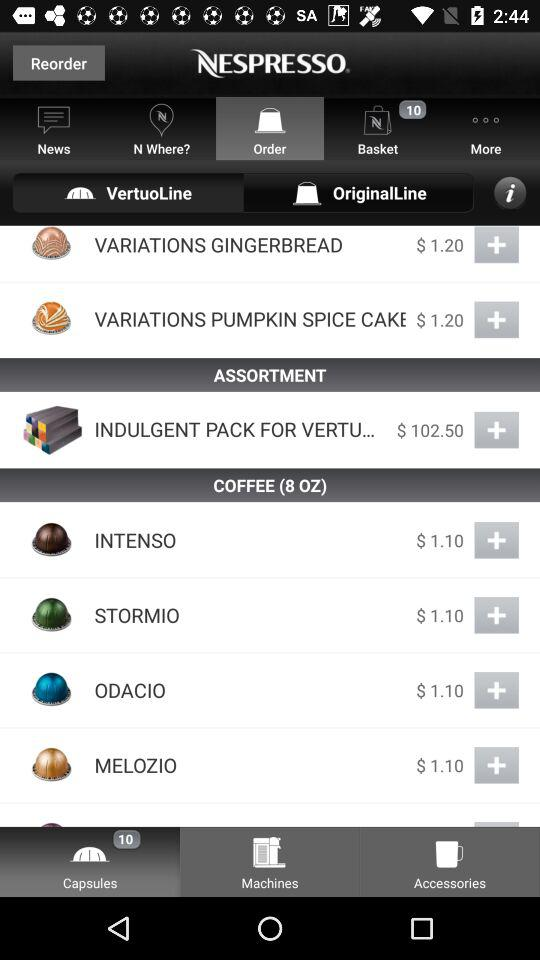What is the price of "INTENSO"? The price is $1.10. 